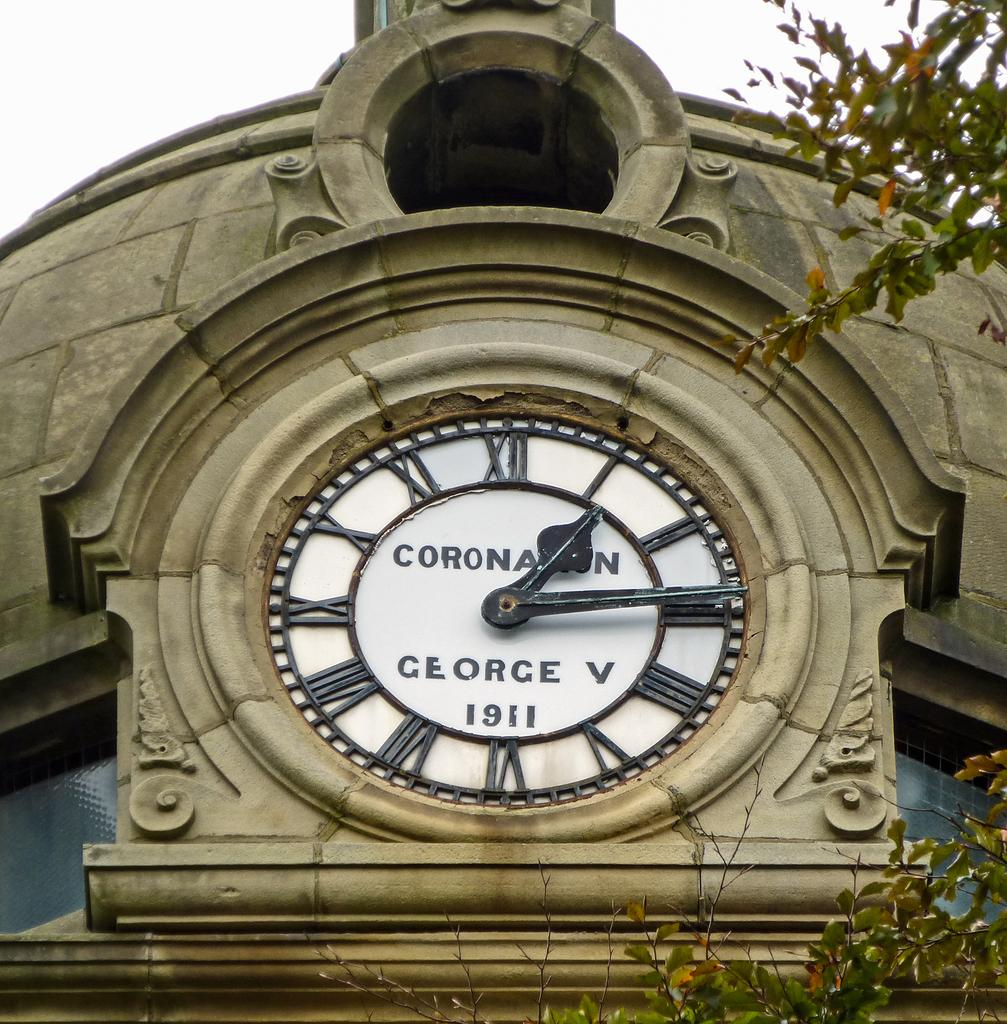<image>
Share a concise interpretation of the image provided. old timeless clock displayed outside coranation  george v 